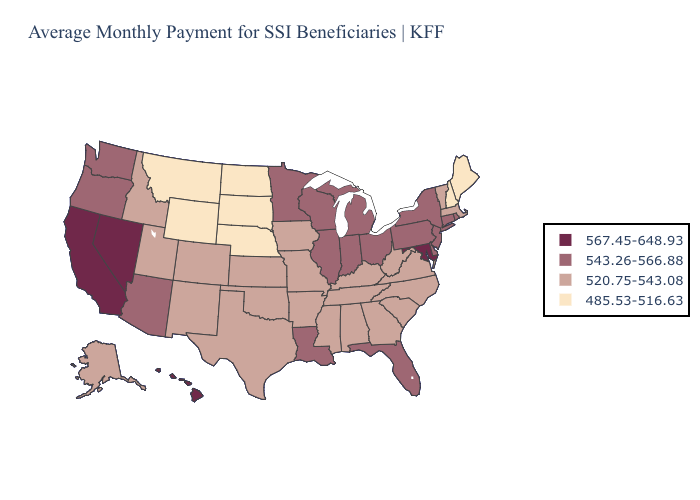Which states have the highest value in the USA?
Quick response, please. California, Hawaii, Maryland, Nevada. Does the first symbol in the legend represent the smallest category?
Quick response, please. No. Name the states that have a value in the range 543.26-566.88?
Be succinct. Arizona, Connecticut, Delaware, Florida, Illinois, Indiana, Louisiana, Michigan, Minnesota, New Jersey, New York, Ohio, Oregon, Pennsylvania, Rhode Island, Washington, Wisconsin. Name the states that have a value in the range 543.26-566.88?
Be succinct. Arizona, Connecticut, Delaware, Florida, Illinois, Indiana, Louisiana, Michigan, Minnesota, New Jersey, New York, Ohio, Oregon, Pennsylvania, Rhode Island, Washington, Wisconsin. Among the states that border Arizona , does Utah have the highest value?
Keep it brief. No. What is the value of Iowa?
Keep it brief. 520.75-543.08. Which states have the highest value in the USA?
Give a very brief answer. California, Hawaii, Maryland, Nevada. Name the states that have a value in the range 485.53-516.63?
Answer briefly. Maine, Montana, Nebraska, New Hampshire, North Dakota, South Dakota, Wyoming. Does Nevada have a higher value than Tennessee?
Keep it brief. Yes. Does Massachusetts have the highest value in the Northeast?
Answer briefly. No. Does Vermont have the highest value in the Northeast?
Concise answer only. No. Does the map have missing data?
Be succinct. No. What is the highest value in the USA?
Answer briefly. 567.45-648.93. What is the value of Maine?
Answer briefly. 485.53-516.63. Does California have the highest value in the USA?
Short answer required. Yes. 